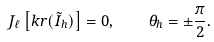<formula> <loc_0><loc_0><loc_500><loc_500>J _ { \ell } \left [ k r ( \tilde { I } _ { h } ) \right ] = 0 , \quad \theta _ { h } = \pm \frac { \pi } { 2 } .</formula> 